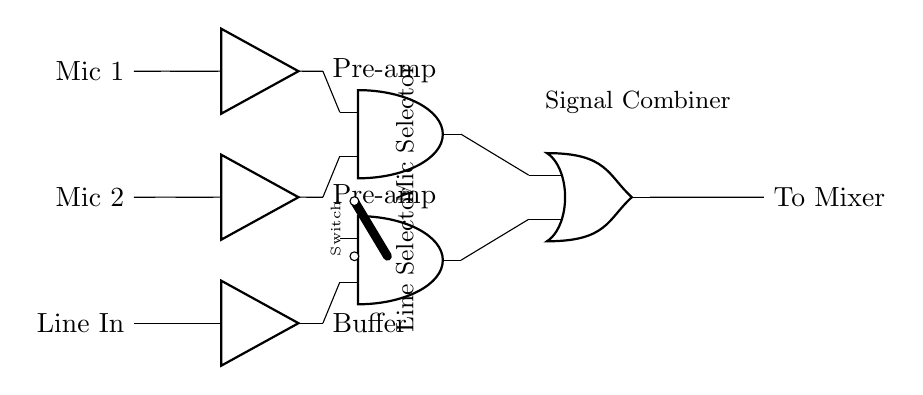What are the input signals? The input signals are Mic 1, Mic 2, and Line In, which are shown connected on the left side of the circuit diagram.
Answer: Mic 1, Mic 2, Line In What is the output of the circuit? The output is labeled "To Mixer," which connects from the output of the OR gate on the right side of the circuit diagram.
Answer: To Mixer What type of logic gate is used for signal combining? An OR gate is used for signal combining, as indicated by the symbol and labeling of the component on the right side of the circuit.
Answer: OR gate How many AND gates are present in the circuit? There are two AND gates present in the circuit, represented by the two AND gate symbols on the left side of the signal combiner.
Answer: Two What do the switches allow in the circuit? The switches allow selection between the microphone input signals and the line input, facilitating signal routing based on the position of the switches.
Answer: Selection Which component types are included in this circuit? The components include amplifiers, AND gates, an OR gate, and a switch, as shown by the various symbols in the diagram.
Answer: Amplifiers, AND gates, OR gate, switch What is the function of the buffer in this circuit? The function of the buffer is to isolate the line input to prevent loading effects on the connected source, allowing for effective signal processing.
Answer: Isolation 